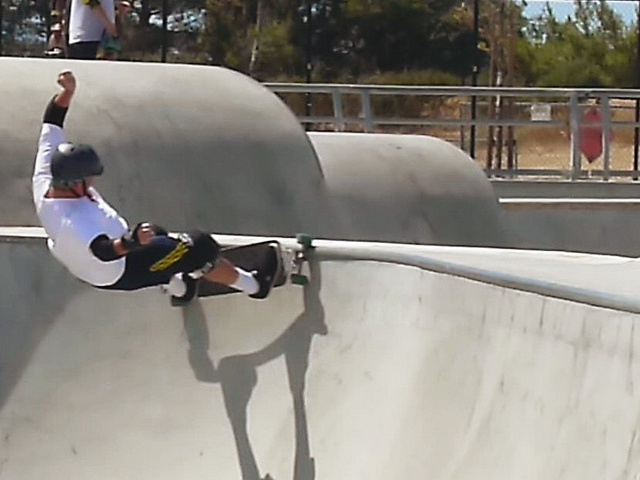Describe the objects in this image and their specific colors. I can see people in black, darkgray, and gray tones, skateboard in black, gray, and darkgray tones, people in black, gray, lightgray, and darkgray tones, and people in black, gray, and darkgray tones in this image. 